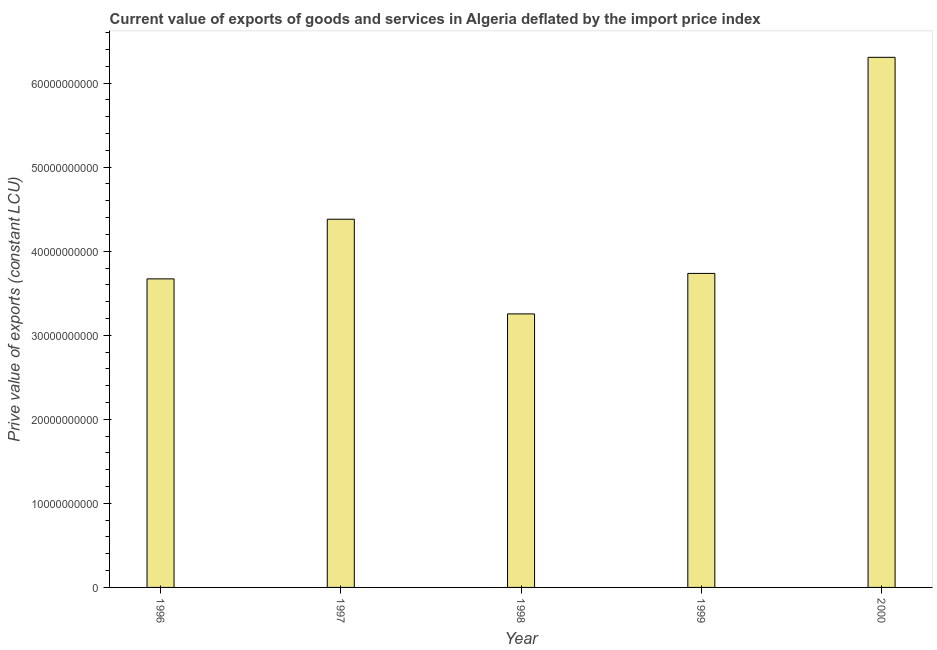What is the title of the graph?
Ensure brevity in your answer.  Current value of exports of goods and services in Algeria deflated by the import price index. What is the label or title of the X-axis?
Provide a short and direct response. Year. What is the label or title of the Y-axis?
Your answer should be very brief. Prive value of exports (constant LCU). What is the price value of exports in 1998?
Offer a very short reply. 3.25e+1. Across all years, what is the maximum price value of exports?
Your response must be concise. 6.31e+1. Across all years, what is the minimum price value of exports?
Your answer should be very brief. 3.25e+1. What is the sum of the price value of exports?
Provide a succinct answer. 2.13e+11. What is the difference between the price value of exports in 1996 and 1999?
Keep it short and to the point. -6.49e+08. What is the average price value of exports per year?
Your response must be concise. 4.27e+1. What is the median price value of exports?
Offer a very short reply. 3.74e+1. In how many years, is the price value of exports greater than 44000000000 LCU?
Your answer should be compact. 1. What is the ratio of the price value of exports in 1997 to that in 1998?
Offer a very short reply. 1.35. Is the price value of exports in 1997 less than that in 2000?
Your answer should be very brief. Yes. What is the difference between the highest and the second highest price value of exports?
Give a very brief answer. 1.93e+1. What is the difference between the highest and the lowest price value of exports?
Your answer should be compact. 3.05e+1. How many bars are there?
Ensure brevity in your answer.  5. Are all the bars in the graph horizontal?
Keep it short and to the point. No. How many years are there in the graph?
Provide a succinct answer. 5. What is the difference between two consecutive major ticks on the Y-axis?
Make the answer very short. 1.00e+1. What is the Prive value of exports (constant LCU) of 1996?
Your answer should be very brief. 3.67e+1. What is the Prive value of exports (constant LCU) of 1997?
Give a very brief answer. 4.38e+1. What is the Prive value of exports (constant LCU) in 1998?
Offer a terse response. 3.25e+1. What is the Prive value of exports (constant LCU) in 1999?
Keep it short and to the point. 3.74e+1. What is the Prive value of exports (constant LCU) in 2000?
Offer a terse response. 6.31e+1. What is the difference between the Prive value of exports (constant LCU) in 1996 and 1997?
Make the answer very short. -7.10e+09. What is the difference between the Prive value of exports (constant LCU) in 1996 and 1998?
Make the answer very short. 4.17e+09. What is the difference between the Prive value of exports (constant LCU) in 1996 and 1999?
Your response must be concise. -6.49e+08. What is the difference between the Prive value of exports (constant LCU) in 1996 and 2000?
Keep it short and to the point. -2.64e+1. What is the difference between the Prive value of exports (constant LCU) in 1997 and 1998?
Keep it short and to the point. 1.13e+1. What is the difference between the Prive value of exports (constant LCU) in 1997 and 1999?
Make the answer very short. 6.45e+09. What is the difference between the Prive value of exports (constant LCU) in 1997 and 2000?
Offer a very short reply. -1.93e+1. What is the difference between the Prive value of exports (constant LCU) in 1998 and 1999?
Offer a terse response. -4.82e+09. What is the difference between the Prive value of exports (constant LCU) in 1998 and 2000?
Provide a short and direct response. -3.05e+1. What is the difference between the Prive value of exports (constant LCU) in 1999 and 2000?
Your response must be concise. -2.57e+1. What is the ratio of the Prive value of exports (constant LCU) in 1996 to that in 1997?
Offer a very short reply. 0.84. What is the ratio of the Prive value of exports (constant LCU) in 1996 to that in 1998?
Offer a terse response. 1.13. What is the ratio of the Prive value of exports (constant LCU) in 1996 to that in 1999?
Your response must be concise. 0.98. What is the ratio of the Prive value of exports (constant LCU) in 1996 to that in 2000?
Ensure brevity in your answer.  0.58. What is the ratio of the Prive value of exports (constant LCU) in 1997 to that in 1998?
Provide a succinct answer. 1.35. What is the ratio of the Prive value of exports (constant LCU) in 1997 to that in 1999?
Ensure brevity in your answer.  1.17. What is the ratio of the Prive value of exports (constant LCU) in 1997 to that in 2000?
Give a very brief answer. 0.69. What is the ratio of the Prive value of exports (constant LCU) in 1998 to that in 1999?
Keep it short and to the point. 0.87. What is the ratio of the Prive value of exports (constant LCU) in 1998 to that in 2000?
Offer a very short reply. 0.52. What is the ratio of the Prive value of exports (constant LCU) in 1999 to that in 2000?
Give a very brief answer. 0.59. 